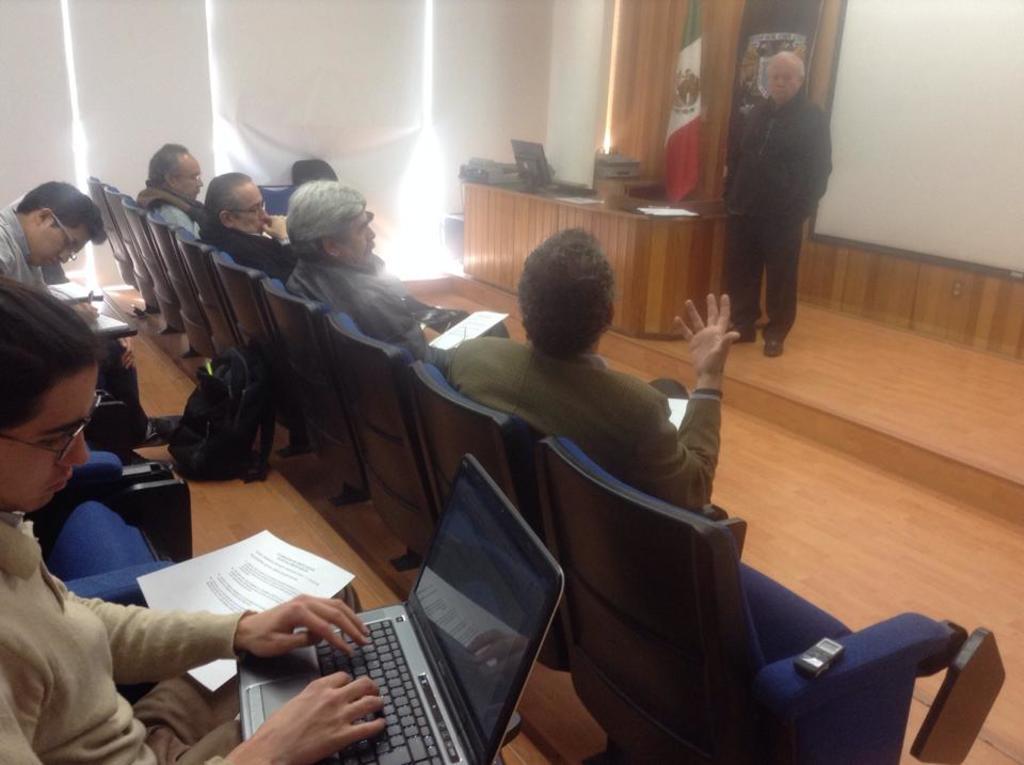How would you summarize this image in a sentence or two? In the foreground of this picture, there are persons sitting on the chairs and a person is holding a laptop on his legs. In the background, there is a man standing, few objects on the desk, flag, and a white wall. 